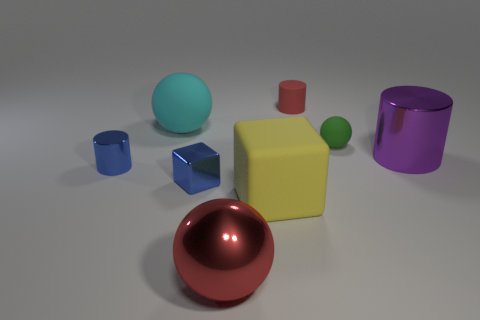Is the number of tiny green metal blocks greater than the number of small matte balls?
Your answer should be compact. No. What is the material of the large cyan ball?
Your response must be concise. Rubber. The ball to the left of the red metallic sphere is what color?
Ensure brevity in your answer.  Cyan. Is the number of objects to the left of the big rubber ball greater than the number of purple metal things that are in front of the small cube?
Give a very brief answer. Yes. What is the size of the matte thing that is on the left side of the big ball that is in front of the large ball that is behind the large rubber block?
Provide a succinct answer. Large. Are there any objects of the same color as the tiny metal cylinder?
Provide a succinct answer. Yes. What number of large blocks are there?
Your response must be concise. 1. What material is the red object in front of the cylinder that is left of the big cyan rubber object to the left of the red metal sphere made of?
Your answer should be very brief. Metal. Are there any blue blocks made of the same material as the tiny red cylinder?
Make the answer very short. No. Do the large purple cylinder and the tiny green object have the same material?
Provide a short and direct response. No. 